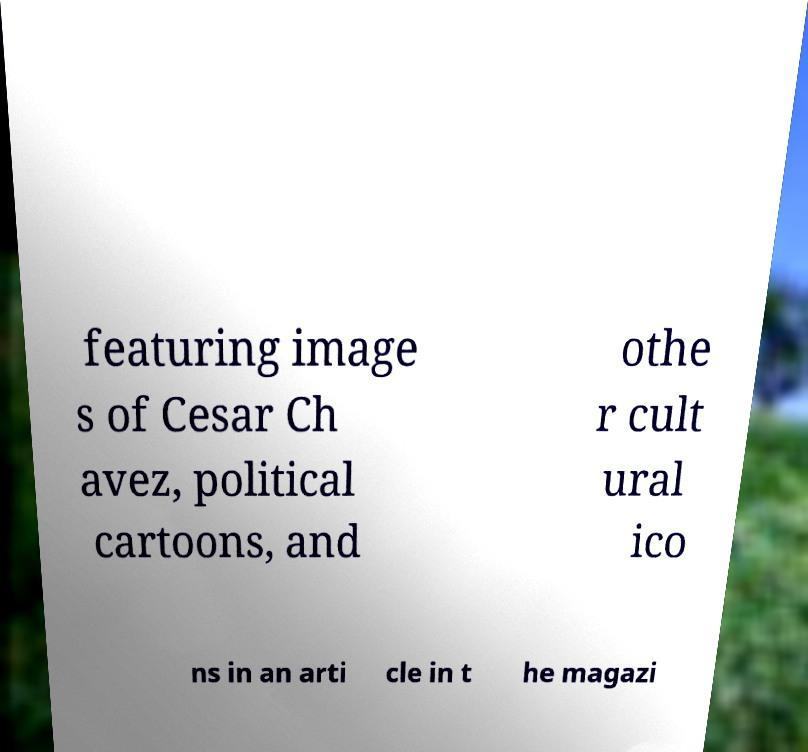Could you extract and type out the text from this image? featuring image s of Cesar Ch avez, political cartoons, and othe r cult ural ico ns in an arti cle in t he magazi 